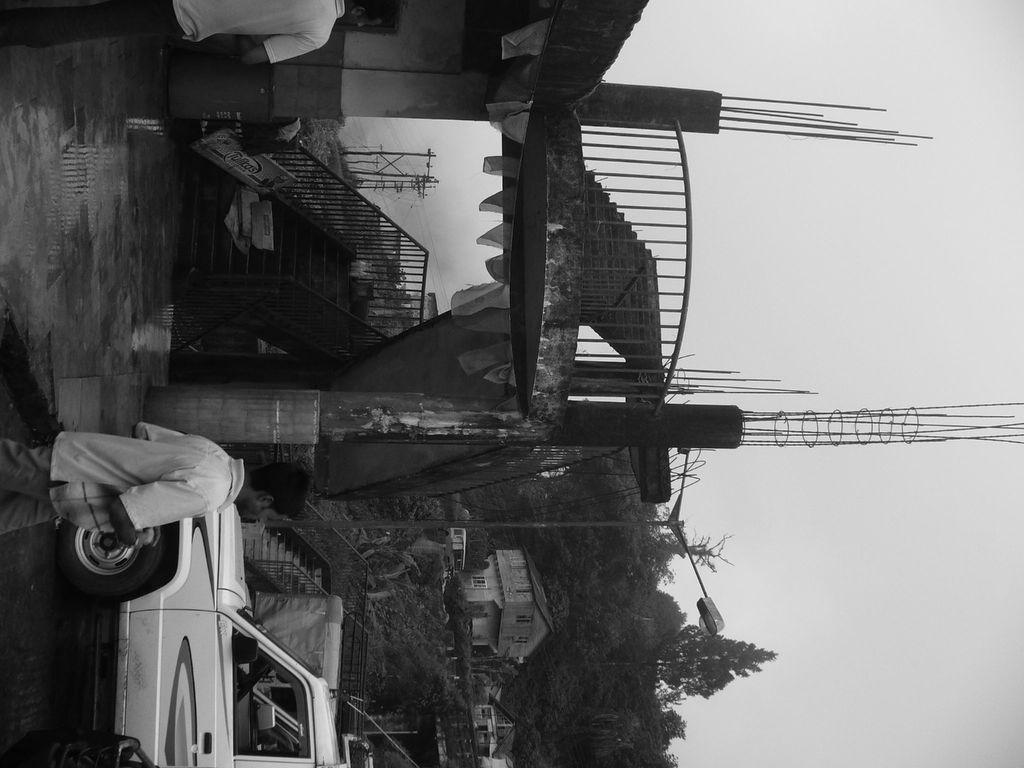Please provide a concise description of this image. In this image I can see two persons standing and I can also see few vehicles. In the background I can see few houses, light poles, trees in green color and I can also see the sky and the image is in black and white. 